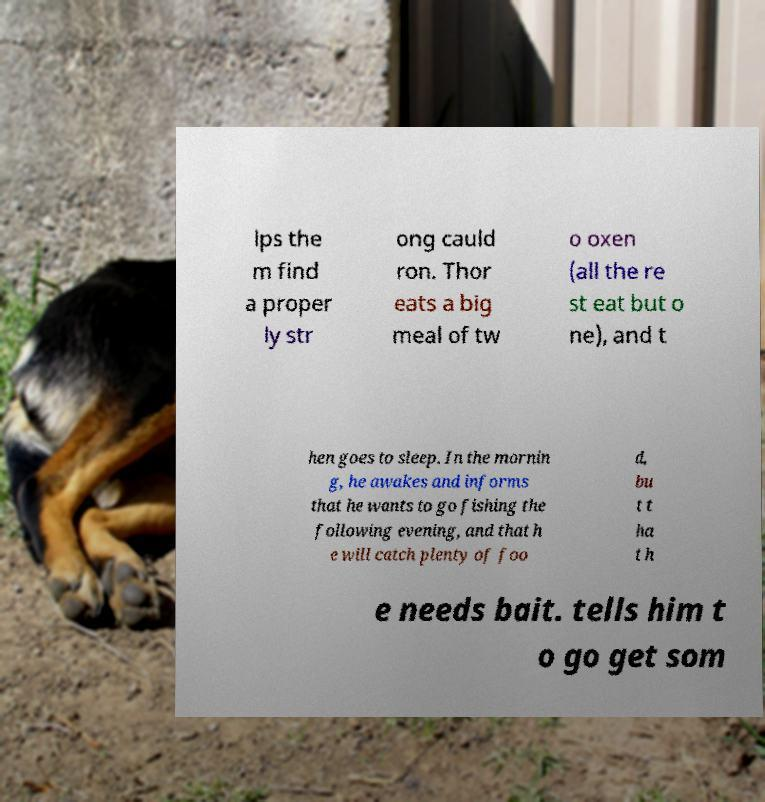I need the written content from this picture converted into text. Can you do that? lps the m find a proper ly str ong cauld ron. Thor eats a big meal of tw o oxen (all the re st eat but o ne), and t hen goes to sleep. In the mornin g, he awakes and informs that he wants to go fishing the following evening, and that h e will catch plenty of foo d, bu t t ha t h e needs bait. tells him t o go get som 